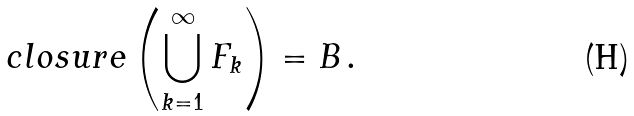Convert formula to latex. <formula><loc_0><loc_0><loc_500><loc_500>c l o s u r e \left ( \bigcup _ { k = 1 } ^ { \infty } F _ { k } \right ) = B \, .</formula> 